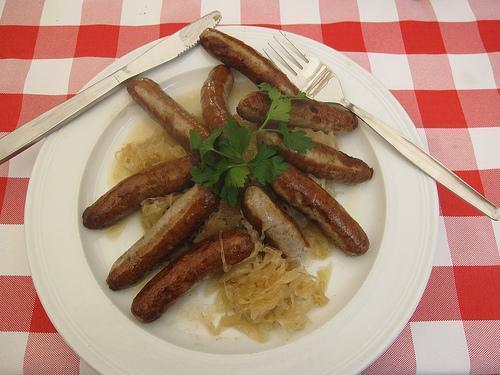How many people are eating food?
Give a very brief answer. 0. 